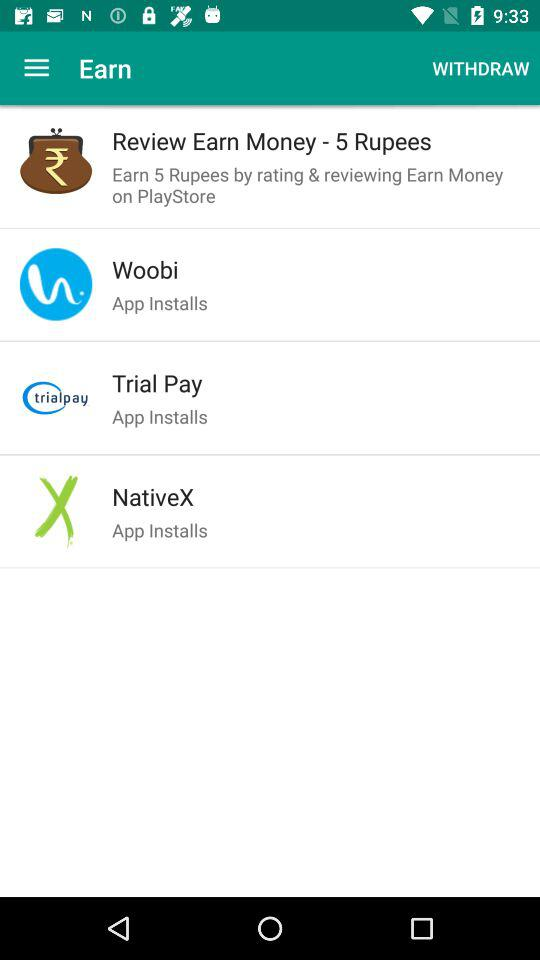How much money will we earn by rating and reviewing? You will earn 5 rupees by rating and reviewing. 